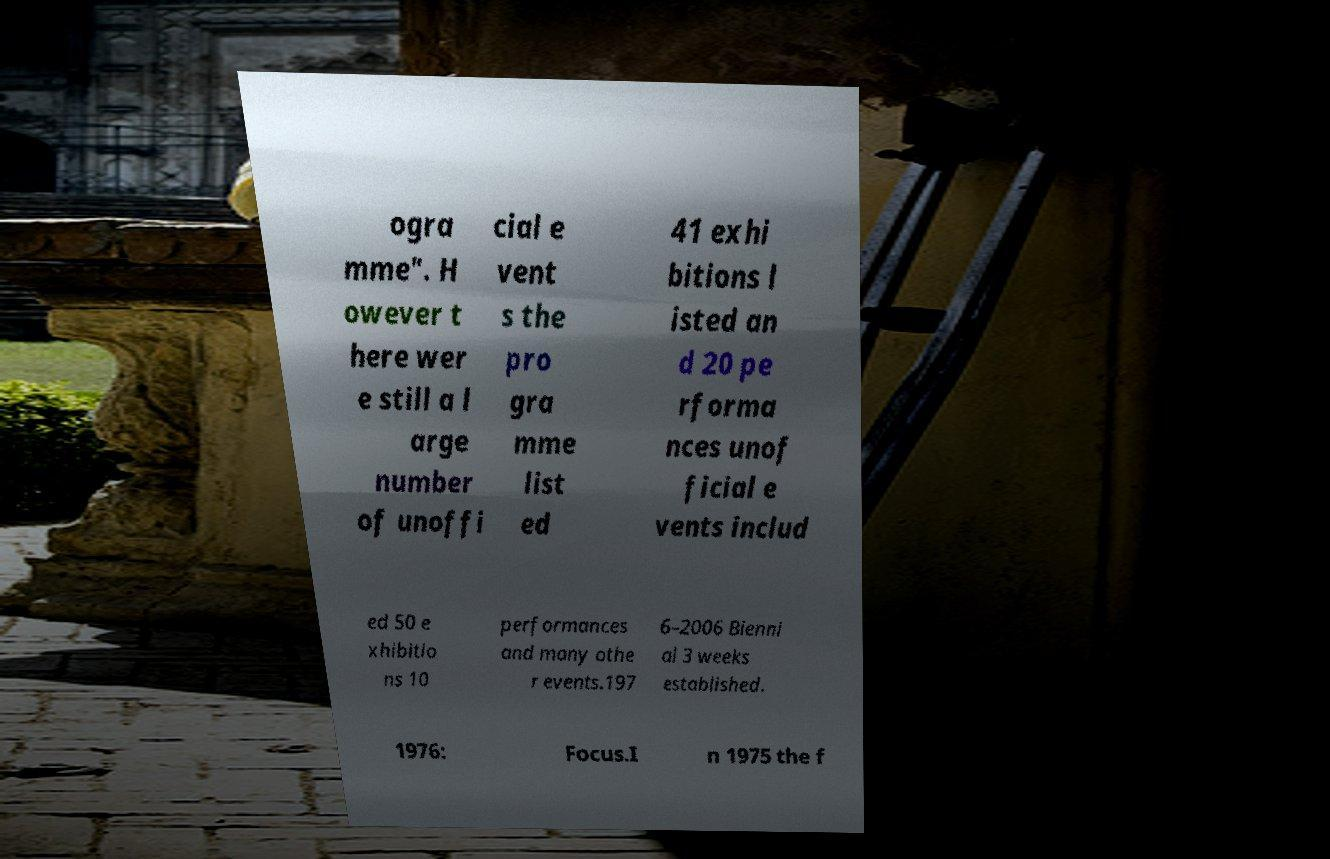What messages or text are displayed in this image? I need them in a readable, typed format. ogra mme". H owever t here wer e still a l arge number of unoffi cial e vent s the pro gra mme list ed 41 exhi bitions l isted an d 20 pe rforma nces unof ficial e vents includ ed 50 e xhibitio ns 10 performances and many othe r events.197 6–2006 Bienni al 3 weeks established. 1976: Focus.I n 1975 the f 